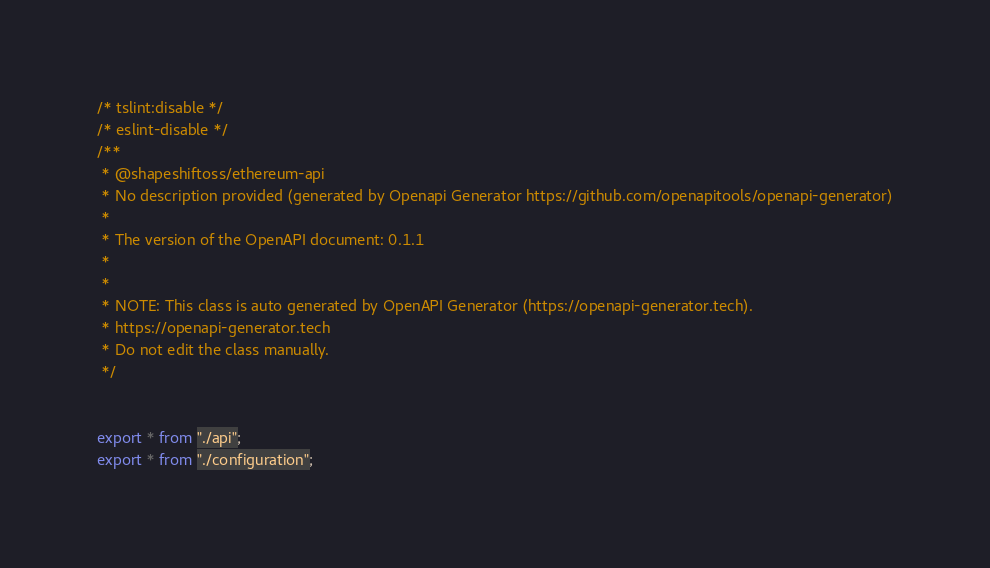Convert code to text. <code><loc_0><loc_0><loc_500><loc_500><_TypeScript_>/* tslint:disable */
/* eslint-disable */
/**
 * @shapeshiftoss/ethereum-api
 * No description provided (generated by Openapi Generator https://github.com/openapitools/openapi-generator)
 *
 * The version of the OpenAPI document: 0.1.1
 * 
 *
 * NOTE: This class is auto generated by OpenAPI Generator (https://openapi-generator.tech).
 * https://openapi-generator.tech
 * Do not edit the class manually.
 */


export * from "./api";
export * from "./configuration";

</code> 